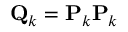<formula> <loc_0><loc_0><loc_500><loc_500>Q _ { k } = P _ { k } P _ { k }</formula> 